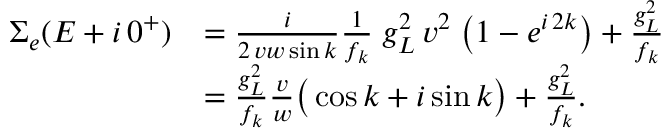<formula> <loc_0><loc_0><loc_500><loc_500>\begin{array} { r l } { \Sigma _ { e } ( E + i \, 0 ^ { + } ) } & { = \frac { i } { 2 \, v w \sin { k } } \frac { 1 } { f _ { k } } \, g _ { L } ^ { 2 } \, v ^ { 2 } \, \left ( 1 - e ^ { i \, 2 k } \right ) + \frac { g _ { L } ^ { 2 } } { f _ { k } } } \\ & { = \frac { g _ { L } ^ { 2 } } { f _ { k } } \frac { v } { w } \left ( \cos { k } + i \sin { k } \right ) + \frac { g _ { L } ^ { 2 } } { f _ { k } } . } \end{array}</formula> 